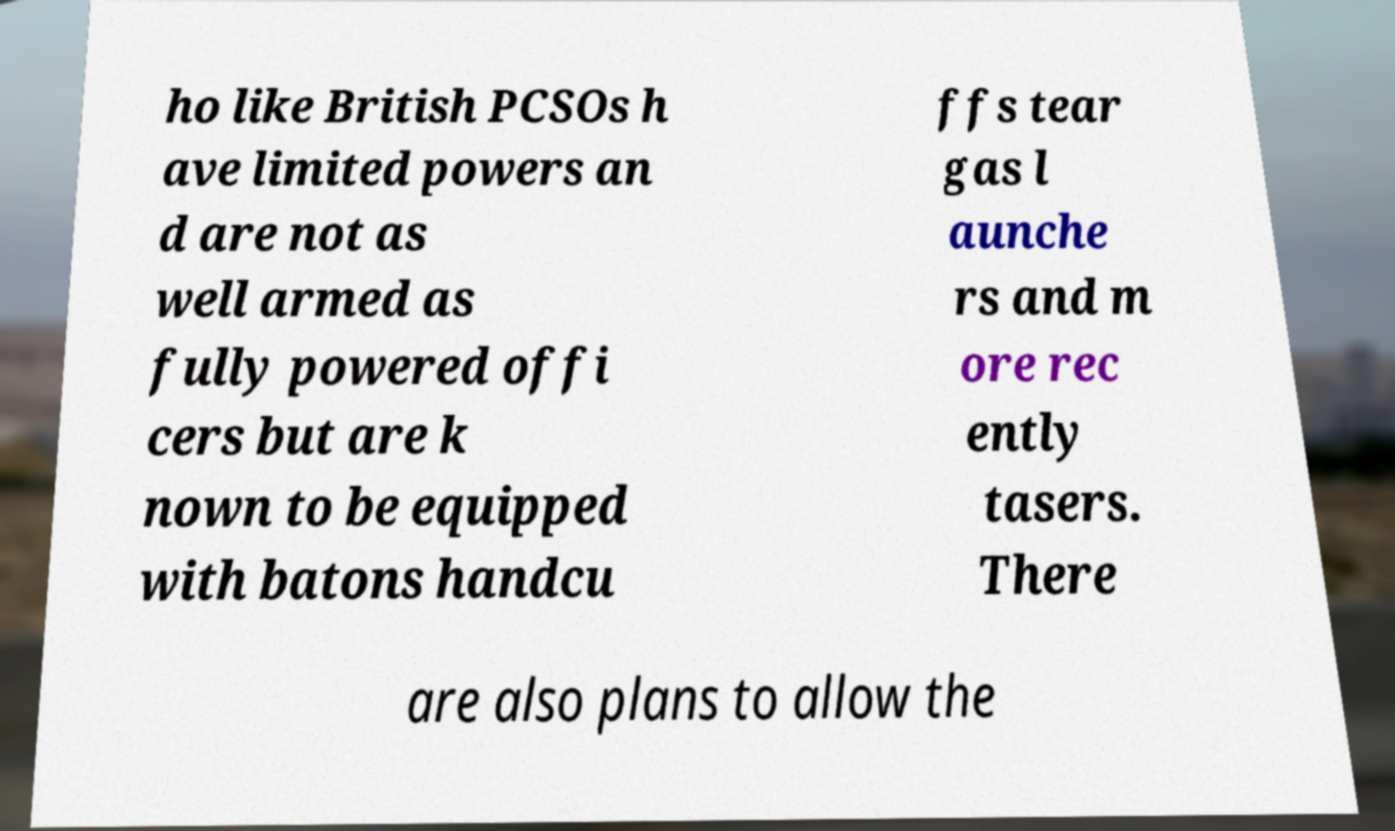Could you extract and type out the text from this image? ho like British PCSOs h ave limited powers an d are not as well armed as fully powered offi cers but are k nown to be equipped with batons handcu ffs tear gas l aunche rs and m ore rec ently tasers. There are also plans to allow the 